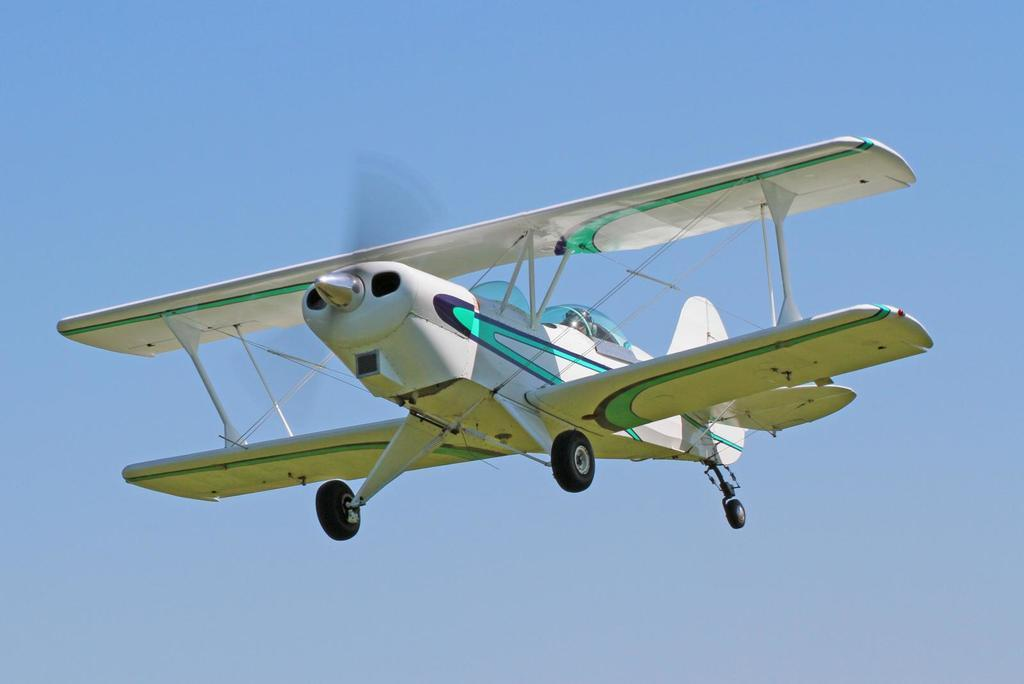What is the main subject of the image? The main subject of the image is an aircraft. Can you describe the position of the aircraft in the image? The aircraft is in the air in the image. What can be seen in the background of the image? The sky is visible in the background of the image. How many spiders are crawling on the aircraft in the image? There are no spiders visible on the aircraft in the image. What type of straw is being used to drink from the aircraft's fuel tank in the image? There is no straw or fuel tank present in the image; it only features an aircraft in the air. 